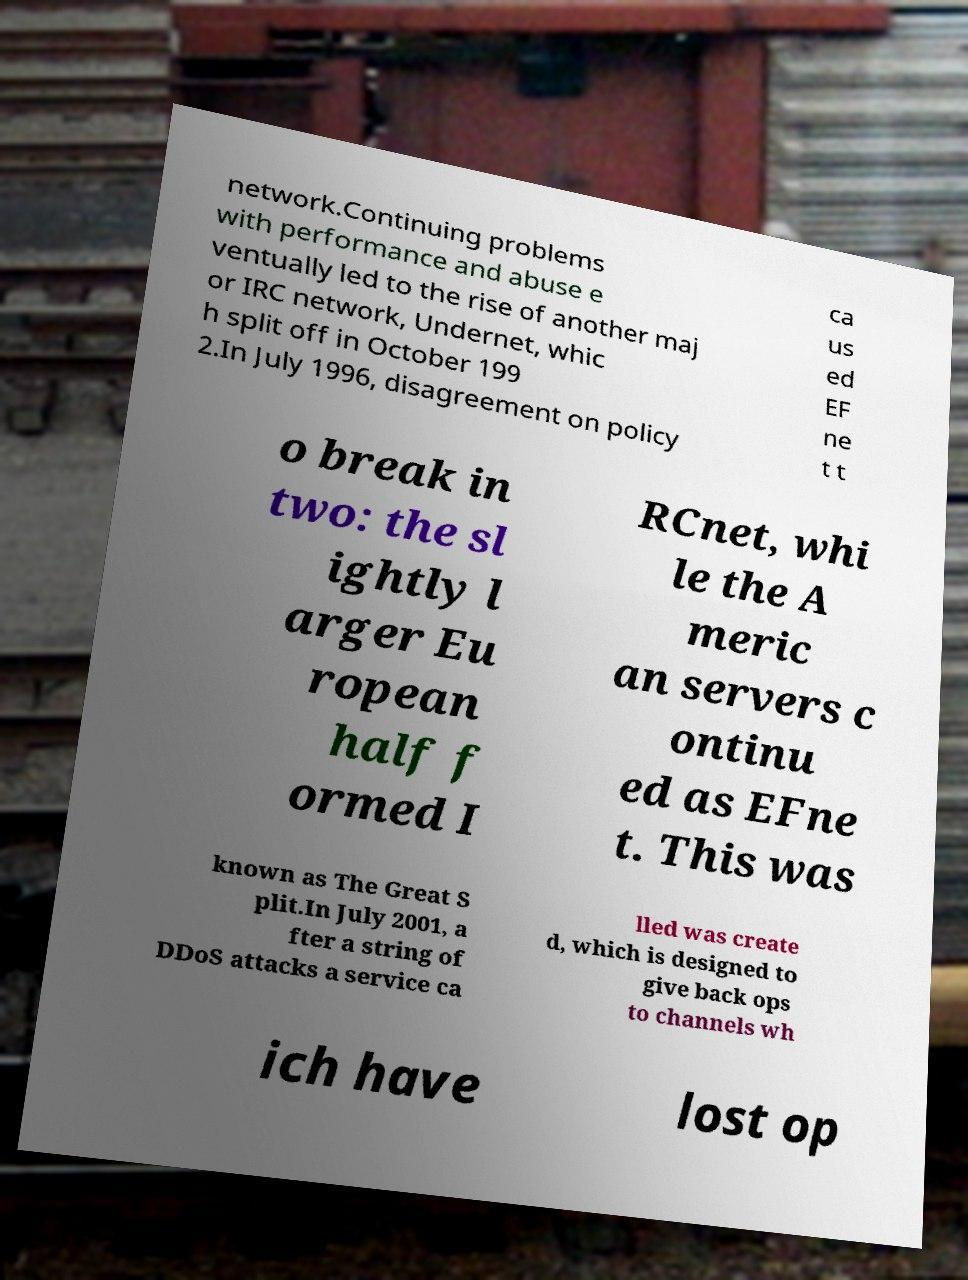Can you read and provide the text displayed in the image?This photo seems to have some interesting text. Can you extract and type it out for me? network.Continuing problems with performance and abuse e ventually led to the rise of another maj or IRC network, Undernet, whic h split off in October 199 2.In July 1996, disagreement on policy ca us ed EF ne t t o break in two: the sl ightly l arger Eu ropean half f ormed I RCnet, whi le the A meric an servers c ontinu ed as EFne t. This was known as The Great S plit.In July 2001, a fter a string of DDoS attacks a service ca lled was create d, which is designed to give back ops to channels wh ich have lost op 